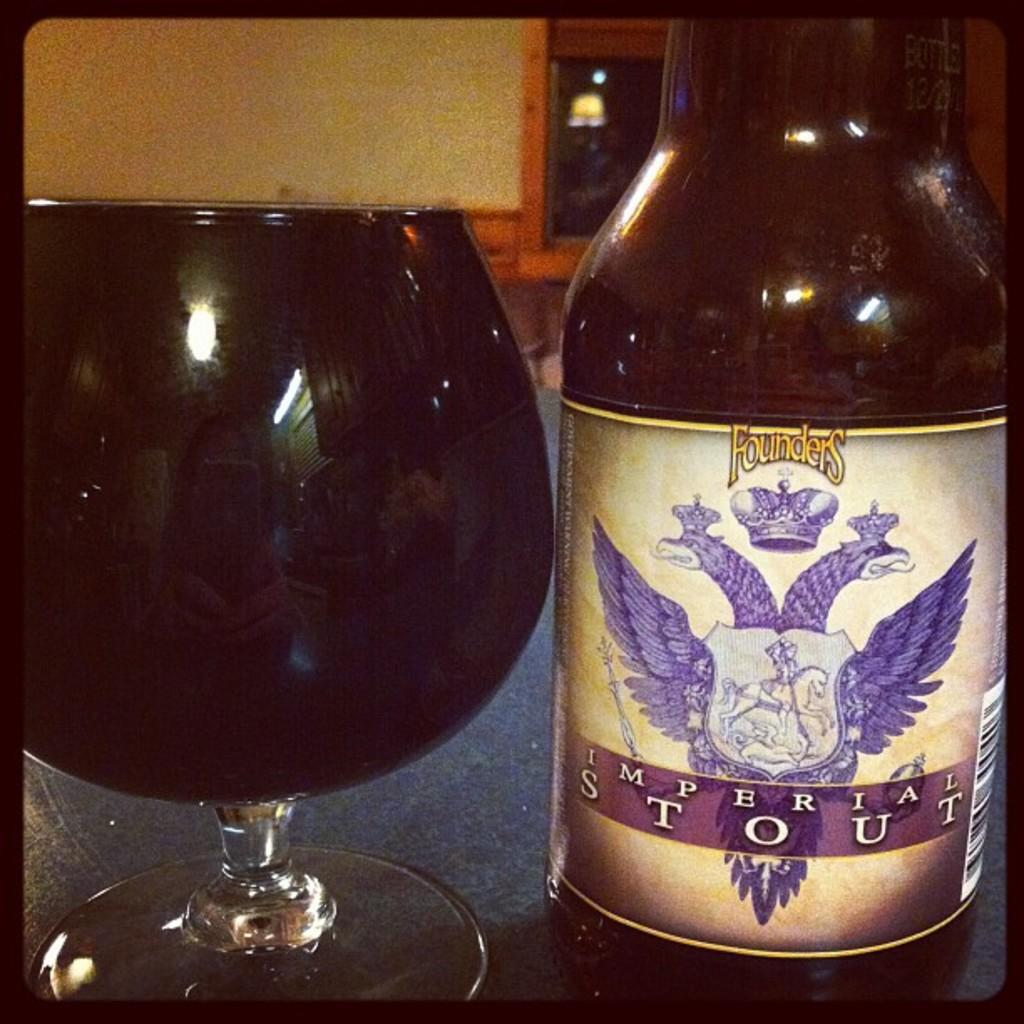<image>
Write a terse but informative summary of the picture. A bottle is sitting next to a glass full of Founders Imperial Stout. 